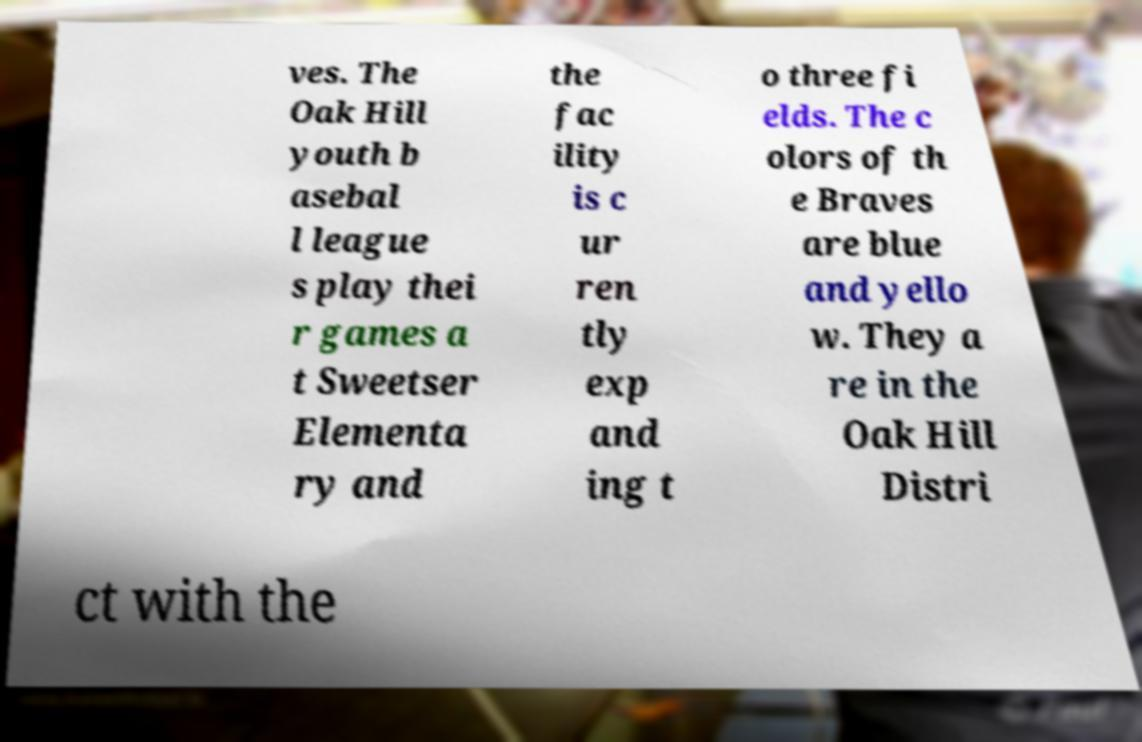Can you accurately transcribe the text from the provided image for me? ves. The Oak Hill youth b asebal l league s play thei r games a t Sweetser Elementa ry and the fac ility is c ur ren tly exp and ing t o three fi elds. The c olors of th e Braves are blue and yello w. They a re in the Oak Hill Distri ct with the 